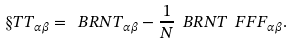Convert formula to latex. <formula><loc_0><loc_0><loc_500><loc_500>\S T T _ { \alpha \beta } = \ B R N { T } _ { \alpha \beta } - \frac { 1 } { N } \ B R N { T } \ F F F _ { \alpha \beta } .</formula> 